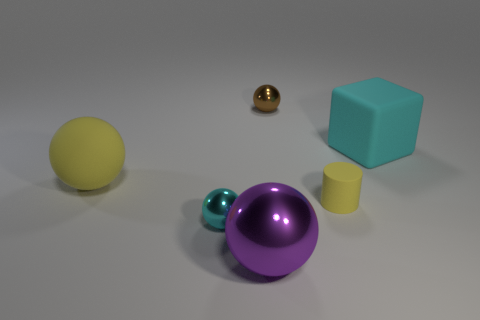Are there any big red rubber things that have the same shape as the cyan rubber thing?
Offer a very short reply. No. Is the color of the large ball behind the cylinder the same as the big sphere in front of the cyan metallic object?
Offer a terse response. No. There is a rubber cylinder; are there any cyan blocks in front of it?
Provide a succinct answer. No. What is the big object that is to the left of the yellow matte cylinder and behind the big shiny object made of?
Your response must be concise. Rubber. Do the ball that is in front of the tiny cyan metal ball and the yellow ball have the same material?
Provide a succinct answer. No. What material is the big cyan block?
Offer a very short reply. Rubber. What is the size of the object that is behind the cyan block?
Provide a short and direct response. Small. Are there any other things that have the same color as the matte cube?
Ensure brevity in your answer.  Yes. There is a large yellow thing in front of the matte thing on the right side of the cylinder; are there any big rubber blocks that are behind it?
Keep it short and to the point. Yes. Does the small metal ball that is to the left of the tiny brown sphere have the same color as the small matte cylinder?
Make the answer very short. No. 